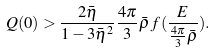<formula> <loc_0><loc_0><loc_500><loc_500>Q ( 0 ) > \frac { 2 \bar { \eta } } { 1 - 3 \bar { \eta } ^ { 2 } } \frac { 4 \pi } { 3 } \bar { \rho } \, f ( \frac { E } { \frac { 4 \pi } { 3 } \bar { \rho } } ) .</formula> 